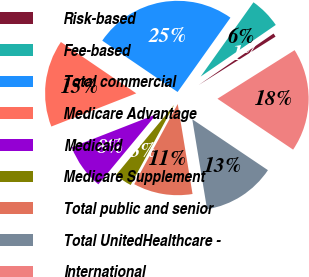<chart> <loc_0><loc_0><loc_500><loc_500><pie_chart><fcel>Risk-based<fcel>Fee-based<fcel>Total commercial<fcel>Medicare Advantage<fcel>Medicaid<fcel>Medicare Supplement<fcel>Total public and senior<fcel>Total UnitedHealthcare -<fcel>International<nl><fcel>0.64%<fcel>5.58%<fcel>25.32%<fcel>15.45%<fcel>8.05%<fcel>3.11%<fcel>10.51%<fcel>12.98%<fcel>18.37%<nl></chart> 